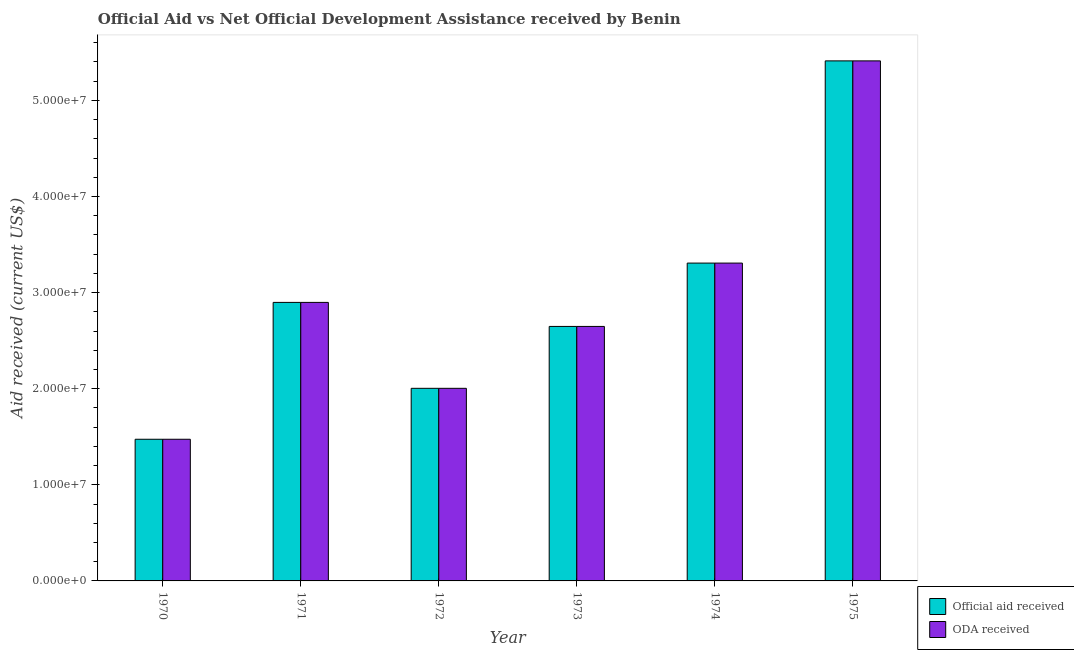How many groups of bars are there?
Provide a succinct answer. 6. Are the number of bars per tick equal to the number of legend labels?
Ensure brevity in your answer.  Yes. Are the number of bars on each tick of the X-axis equal?
Your response must be concise. Yes. What is the label of the 4th group of bars from the left?
Your answer should be compact. 1973. In how many cases, is the number of bars for a given year not equal to the number of legend labels?
Ensure brevity in your answer.  0. What is the oda received in 1973?
Give a very brief answer. 2.65e+07. Across all years, what is the maximum official aid received?
Give a very brief answer. 5.41e+07. Across all years, what is the minimum official aid received?
Ensure brevity in your answer.  1.47e+07. In which year was the oda received maximum?
Provide a succinct answer. 1975. What is the total oda received in the graph?
Offer a very short reply. 1.77e+08. What is the difference between the official aid received in 1971 and that in 1974?
Your answer should be compact. -4.09e+06. What is the difference between the official aid received in 1971 and the oda received in 1973?
Your response must be concise. 2.50e+06. What is the average oda received per year?
Your answer should be very brief. 2.96e+07. In the year 1975, what is the difference between the official aid received and oda received?
Keep it short and to the point. 0. In how many years, is the oda received greater than 26000000 US$?
Your answer should be very brief. 4. What is the ratio of the oda received in 1974 to that in 1975?
Your answer should be compact. 0.61. Is the official aid received in 1971 less than that in 1974?
Provide a succinct answer. Yes. What is the difference between the highest and the second highest official aid received?
Provide a short and direct response. 2.10e+07. What is the difference between the highest and the lowest oda received?
Your answer should be compact. 3.94e+07. In how many years, is the official aid received greater than the average official aid received taken over all years?
Offer a very short reply. 2. What does the 1st bar from the left in 1971 represents?
Provide a short and direct response. Official aid received. What does the 1st bar from the right in 1975 represents?
Give a very brief answer. ODA received. How many bars are there?
Ensure brevity in your answer.  12. How many years are there in the graph?
Provide a short and direct response. 6. Are the values on the major ticks of Y-axis written in scientific E-notation?
Offer a terse response. Yes. Does the graph contain grids?
Make the answer very short. No. Where does the legend appear in the graph?
Offer a very short reply. Bottom right. How are the legend labels stacked?
Keep it short and to the point. Vertical. What is the title of the graph?
Offer a very short reply. Official Aid vs Net Official Development Assistance received by Benin . Does "Non-solid fuel" appear as one of the legend labels in the graph?
Provide a short and direct response. No. What is the label or title of the Y-axis?
Your answer should be compact. Aid received (current US$). What is the Aid received (current US$) of Official aid received in 1970?
Provide a succinct answer. 1.47e+07. What is the Aid received (current US$) in ODA received in 1970?
Provide a succinct answer. 1.47e+07. What is the Aid received (current US$) in Official aid received in 1971?
Offer a terse response. 2.90e+07. What is the Aid received (current US$) of ODA received in 1971?
Keep it short and to the point. 2.90e+07. What is the Aid received (current US$) of Official aid received in 1972?
Offer a very short reply. 2.00e+07. What is the Aid received (current US$) of ODA received in 1972?
Offer a very short reply. 2.00e+07. What is the Aid received (current US$) in Official aid received in 1973?
Offer a very short reply. 2.65e+07. What is the Aid received (current US$) of ODA received in 1973?
Give a very brief answer. 2.65e+07. What is the Aid received (current US$) of Official aid received in 1974?
Your response must be concise. 3.31e+07. What is the Aid received (current US$) of ODA received in 1974?
Keep it short and to the point. 3.31e+07. What is the Aid received (current US$) in Official aid received in 1975?
Offer a very short reply. 5.41e+07. What is the Aid received (current US$) of ODA received in 1975?
Your response must be concise. 5.41e+07. Across all years, what is the maximum Aid received (current US$) of Official aid received?
Your answer should be compact. 5.41e+07. Across all years, what is the maximum Aid received (current US$) of ODA received?
Offer a very short reply. 5.41e+07. Across all years, what is the minimum Aid received (current US$) of Official aid received?
Make the answer very short. 1.47e+07. Across all years, what is the minimum Aid received (current US$) in ODA received?
Offer a terse response. 1.47e+07. What is the total Aid received (current US$) of Official aid received in the graph?
Offer a terse response. 1.77e+08. What is the total Aid received (current US$) of ODA received in the graph?
Offer a very short reply. 1.77e+08. What is the difference between the Aid received (current US$) of Official aid received in 1970 and that in 1971?
Provide a short and direct response. -1.42e+07. What is the difference between the Aid received (current US$) of ODA received in 1970 and that in 1971?
Your answer should be very brief. -1.42e+07. What is the difference between the Aid received (current US$) of Official aid received in 1970 and that in 1972?
Provide a short and direct response. -5.30e+06. What is the difference between the Aid received (current US$) in ODA received in 1970 and that in 1972?
Your response must be concise. -5.30e+06. What is the difference between the Aid received (current US$) in Official aid received in 1970 and that in 1973?
Your answer should be very brief. -1.17e+07. What is the difference between the Aid received (current US$) of ODA received in 1970 and that in 1973?
Provide a short and direct response. -1.17e+07. What is the difference between the Aid received (current US$) in Official aid received in 1970 and that in 1974?
Make the answer very short. -1.83e+07. What is the difference between the Aid received (current US$) in ODA received in 1970 and that in 1974?
Keep it short and to the point. -1.83e+07. What is the difference between the Aid received (current US$) in Official aid received in 1970 and that in 1975?
Your response must be concise. -3.94e+07. What is the difference between the Aid received (current US$) of ODA received in 1970 and that in 1975?
Ensure brevity in your answer.  -3.94e+07. What is the difference between the Aid received (current US$) in Official aid received in 1971 and that in 1972?
Your answer should be compact. 8.94e+06. What is the difference between the Aid received (current US$) in ODA received in 1971 and that in 1972?
Your answer should be compact. 8.94e+06. What is the difference between the Aid received (current US$) in Official aid received in 1971 and that in 1973?
Keep it short and to the point. 2.50e+06. What is the difference between the Aid received (current US$) of ODA received in 1971 and that in 1973?
Your answer should be compact. 2.50e+06. What is the difference between the Aid received (current US$) of Official aid received in 1971 and that in 1974?
Give a very brief answer. -4.09e+06. What is the difference between the Aid received (current US$) of ODA received in 1971 and that in 1974?
Offer a very short reply. -4.09e+06. What is the difference between the Aid received (current US$) in Official aid received in 1971 and that in 1975?
Give a very brief answer. -2.51e+07. What is the difference between the Aid received (current US$) in ODA received in 1971 and that in 1975?
Provide a short and direct response. -2.51e+07. What is the difference between the Aid received (current US$) of Official aid received in 1972 and that in 1973?
Your response must be concise. -6.44e+06. What is the difference between the Aid received (current US$) in ODA received in 1972 and that in 1973?
Your answer should be compact. -6.44e+06. What is the difference between the Aid received (current US$) in Official aid received in 1972 and that in 1974?
Ensure brevity in your answer.  -1.30e+07. What is the difference between the Aid received (current US$) in ODA received in 1972 and that in 1974?
Your answer should be compact. -1.30e+07. What is the difference between the Aid received (current US$) in Official aid received in 1972 and that in 1975?
Make the answer very short. -3.41e+07. What is the difference between the Aid received (current US$) in ODA received in 1972 and that in 1975?
Your answer should be compact. -3.41e+07. What is the difference between the Aid received (current US$) of Official aid received in 1973 and that in 1974?
Offer a terse response. -6.59e+06. What is the difference between the Aid received (current US$) of ODA received in 1973 and that in 1974?
Offer a very short reply. -6.59e+06. What is the difference between the Aid received (current US$) of Official aid received in 1973 and that in 1975?
Your answer should be compact. -2.76e+07. What is the difference between the Aid received (current US$) in ODA received in 1973 and that in 1975?
Your answer should be compact. -2.76e+07. What is the difference between the Aid received (current US$) of Official aid received in 1974 and that in 1975?
Offer a terse response. -2.10e+07. What is the difference between the Aid received (current US$) in ODA received in 1974 and that in 1975?
Make the answer very short. -2.10e+07. What is the difference between the Aid received (current US$) of Official aid received in 1970 and the Aid received (current US$) of ODA received in 1971?
Provide a short and direct response. -1.42e+07. What is the difference between the Aid received (current US$) of Official aid received in 1970 and the Aid received (current US$) of ODA received in 1972?
Give a very brief answer. -5.30e+06. What is the difference between the Aid received (current US$) of Official aid received in 1970 and the Aid received (current US$) of ODA received in 1973?
Your answer should be compact. -1.17e+07. What is the difference between the Aid received (current US$) of Official aid received in 1970 and the Aid received (current US$) of ODA received in 1974?
Your answer should be very brief. -1.83e+07. What is the difference between the Aid received (current US$) of Official aid received in 1970 and the Aid received (current US$) of ODA received in 1975?
Your response must be concise. -3.94e+07. What is the difference between the Aid received (current US$) in Official aid received in 1971 and the Aid received (current US$) in ODA received in 1972?
Make the answer very short. 8.94e+06. What is the difference between the Aid received (current US$) of Official aid received in 1971 and the Aid received (current US$) of ODA received in 1973?
Provide a succinct answer. 2.50e+06. What is the difference between the Aid received (current US$) of Official aid received in 1971 and the Aid received (current US$) of ODA received in 1974?
Provide a succinct answer. -4.09e+06. What is the difference between the Aid received (current US$) of Official aid received in 1971 and the Aid received (current US$) of ODA received in 1975?
Your answer should be compact. -2.51e+07. What is the difference between the Aid received (current US$) of Official aid received in 1972 and the Aid received (current US$) of ODA received in 1973?
Your answer should be very brief. -6.44e+06. What is the difference between the Aid received (current US$) in Official aid received in 1972 and the Aid received (current US$) in ODA received in 1974?
Offer a very short reply. -1.30e+07. What is the difference between the Aid received (current US$) in Official aid received in 1972 and the Aid received (current US$) in ODA received in 1975?
Keep it short and to the point. -3.41e+07. What is the difference between the Aid received (current US$) of Official aid received in 1973 and the Aid received (current US$) of ODA received in 1974?
Give a very brief answer. -6.59e+06. What is the difference between the Aid received (current US$) of Official aid received in 1973 and the Aid received (current US$) of ODA received in 1975?
Your answer should be very brief. -2.76e+07. What is the difference between the Aid received (current US$) of Official aid received in 1974 and the Aid received (current US$) of ODA received in 1975?
Keep it short and to the point. -2.10e+07. What is the average Aid received (current US$) of Official aid received per year?
Offer a terse response. 2.96e+07. What is the average Aid received (current US$) in ODA received per year?
Provide a short and direct response. 2.96e+07. In the year 1971, what is the difference between the Aid received (current US$) of Official aid received and Aid received (current US$) of ODA received?
Provide a short and direct response. 0. In the year 1973, what is the difference between the Aid received (current US$) in Official aid received and Aid received (current US$) in ODA received?
Your response must be concise. 0. In the year 1974, what is the difference between the Aid received (current US$) of Official aid received and Aid received (current US$) of ODA received?
Make the answer very short. 0. In the year 1975, what is the difference between the Aid received (current US$) in Official aid received and Aid received (current US$) in ODA received?
Your answer should be compact. 0. What is the ratio of the Aid received (current US$) in Official aid received in 1970 to that in 1971?
Provide a short and direct response. 0.51. What is the ratio of the Aid received (current US$) of ODA received in 1970 to that in 1971?
Give a very brief answer. 0.51. What is the ratio of the Aid received (current US$) in Official aid received in 1970 to that in 1972?
Your response must be concise. 0.74. What is the ratio of the Aid received (current US$) in ODA received in 1970 to that in 1972?
Your response must be concise. 0.74. What is the ratio of the Aid received (current US$) in Official aid received in 1970 to that in 1973?
Your answer should be very brief. 0.56. What is the ratio of the Aid received (current US$) in ODA received in 1970 to that in 1973?
Your response must be concise. 0.56. What is the ratio of the Aid received (current US$) in Official aid received in 1970 to that in 1974?
Offer a terse response. 0.45. What is the ratio of the Aid received (current US$) of ODA received in 1970 to that in 1974?
Provide a short and direct response. 0.45. What is the ratio of the Aid received (current US$) of Official aid received in 1970 to that in 1975?
Your response must be concise. 0.27. What is the ratio of the Aid received (current US$) of ODA received in 1970 to that in 1975?
Provide a short and direct response. 0.27. What is the ratio of the Aid received (current US$) of Official aid received in 1971 to that in 1972?
Ensure brevity in your answer.  1.45. What is the ratio of the Aid received (current US$) in ODA received in 1971 to that in 1972?
Give a very brief answer. 1.45. What is the ratio of the Aid received (current US$) of Official aid received in 1971 to that in 1973?
Offer a very short reply. 1.09. What is the ratio of the Aid received (current US$) in ODA received in 1971 to that in 1973?
Offer a terse response. 1.09. What is the ratio of the Aid received (current US$) of Official aid received in 1971 to that in 1974?
Provide a succinct answer. 0.88. What is the ratio of the Aid received (current US$) of ODA received in 1971 to that in 1974?
Your answer should be compact. 0.88. What is the ratio of the Aid received (current US$) in Official aid received in 1971 to that in 1975?
Offer a terse response. 0.54. What is the ratio of the Aid received (current US$) in ODA received in 1971 to that in 1975?
Provide a short and direct response. 0.54. What is the ratio of the Aid received (current US$) of Official aid received in 1972 to that in 1973?
Keep it short and to the point. 0.76. What is the ratio of the Aid received (current US$) of ODA received in 1972 to that in 1973?
Offer a very short reply. 0.76. What is the ratio of the Aid received (current US$) in Official aid received in 1972 to that in 1974?
Keep it short and to the point. 0.61. What is the ratio of the Aid received (current US$) of ODA received in 1972 to that in 1974?
Ensure brevity in your answer.  0.61. What is the ratio of the Aid received (current US$) in Official aid received in 1972 to that in 1975?
Offer a very short reply. 0.37. What is the ratio of the Aid received (current US$) in ODA received in 1972 to that in 1975?
Your answer should be very brief. 0.37. What is the ratio of the Aid received (current US$) in Official aid received in 1973 to that in 1974?
Your answer should be compact. 0.8. What is the ratio of the Aid received (current US$) of ODA received in 1973 to that in 1974?
Keep it short and to the point. 0.8. What is the ratio of the Aid received (current US$) in Official aid received in 1973 to that in 1975?
Provide a short and direct response. 0.49. What is the ratio of the Aid received (current US$) of ODA received in 1973 to that in 1975?
Give a very brief answer. 0.49. What is the ratio of the Aid received (current US$) of Official aid received in 1974 to that in 1975?
Ensure brevity in your answer.  0.61. What is the ratio of the Aid received (current US$) of ODA received in 1974 to that in 1975?
Offer a terse response. 0.61. What is the difference between the highest and the second highest Aid received (current US$) of Official aid received?
Give a very brief answer. 2.10e+07. What is the difference between the highest and the second highest Aid received (current US$) of ODA received?
Keep it short and to the point. 2.10e+07. What is the difference between the highest and the lowest Aid received (current US$) of Official aid received?
Your response must be concise. 3.94e+07. What is the difference between the highest and the lowest Aid received (current US$) in ODA received?
Keep it short and to the point. 3.94e+07. 